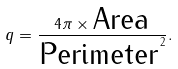<formula> <loc_0><loc_0><loc_500><loc_500>q = \frac { 4 \pi \times \text {Area} } { \text {Perimeter} ^ { 2 } } .</formula> 